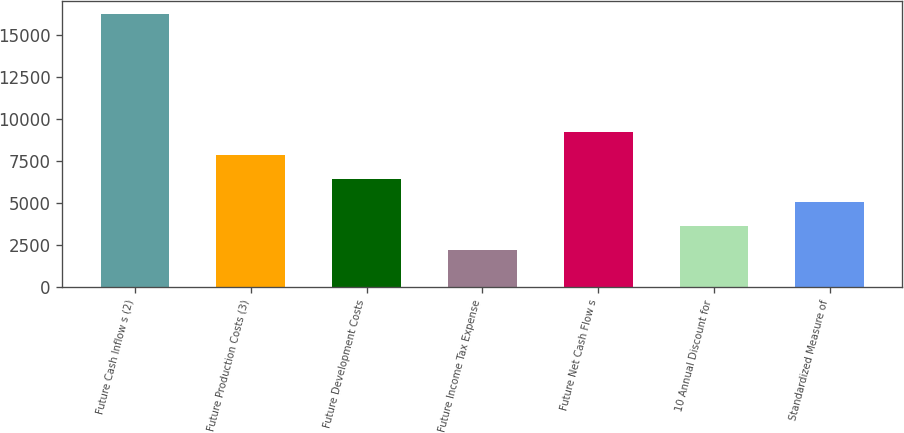Convert chart to OTSL. <chart><loc_0><loc_0><loc_500><loc_500><bar_chart><fcel>Future Cash Inflow s (2)<fcel>Future Production Costs (3)<fcel>Future Development Costs<fcel>Future Income Tax Expense<fcel>Future Net Cash Flow s<fcel>10 Annual Discount for<fcel>Standardized Measure of<nl><fcel>16196<fcel>7814.6<fcel>6417.7<fcel>2227<fcel>9211.5<fcel>3623.9<fcel>5020.8<nl></chart> 